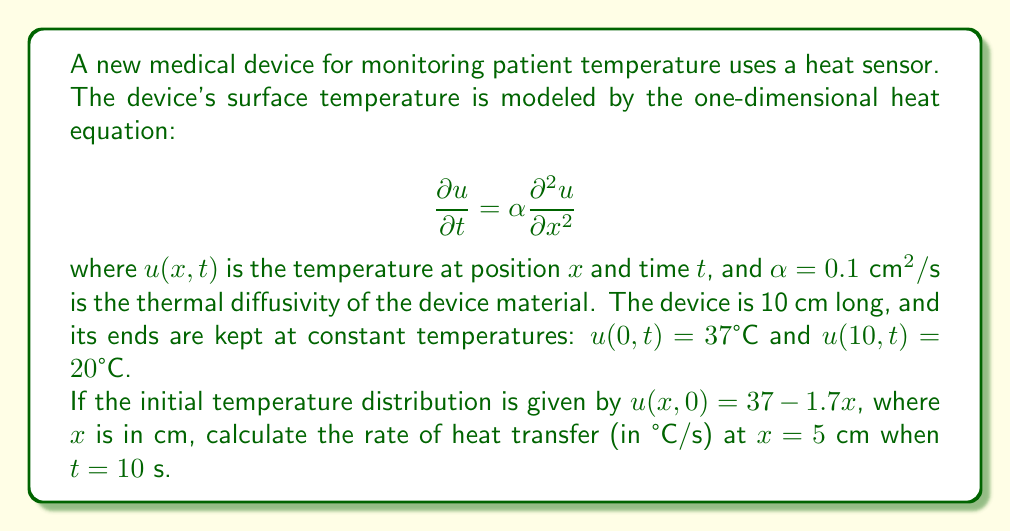Teach me how to tackle this problem. To solve this problem, we need to follow these steps:

1) The general solution to the given heat equation with the specified boundary conditions is:

   $$u(x,t) = 37 - 1.7x + \sum_{n=1}^{\infty} B_n \sin(\frac{n\pi x}{10}) e^{-\alpha(\frac{n\pi}{10})^2 t}$$

   where $B_n$ are constants determined by the initial condition.

2) The rate of heat transfer is given by $-\alpha \frac{\partial^2 u}{\partial x^2}$. We need to calculate this at $x = 5$ cm and $t = 10$ s.

3) Taking the second derivative of $u$ with respect to $x$:

   $$\frac{\partial^2 u}{\partial x^2} = \sum_{n=1}^{\infty} -B_n (\frac{n\pi}{10})^2 \sin(\frac{n\pi x}{10}) e^{-\alpha(\frac{n\pi}{10})^2 t}$$

4) To find $B_n$, we use the initial condition:

   $$37 - 1.7x = 37 - 1.7x + \sum_{n=1}^{\infty} B_n \sin(\frac{n\pi x}{10})$$

   This implies:

   $$B_n = \frac{2}{10} \int_0^{10} (37 - 1.7x) \sin(\frac{n\pi x}{10}) dx = \frac{34}{n\pi} (1 - (-1)^n)$$

5) Now, we can calculate the rate of heat transfer:

   $$\text{Rate} = -\alpha \sum_{n=1}^{\infty} B_n (\frac{n\pi}{10})^2 \sin(\frac{n\pi x}{2}) e^{-\alpha(\frac{n\pi}{10})^2 t}$$

6) Substituting the values $\alpha = 0.1$, $x = 5$, and $t = 10$:

   $$\text{Rate} = -0.1 \sum_{n=1}^{\infty} \frac{34}{n\pi} (1 - (-1)^n) (\frac{n\pi}{10})^2 \sin(\frac{n\pi}{2}) e^{-0.1(\frac{n\pi}{10})^2 10}$$

7) This series converges rapidly. Calculating the first few terms (odd n only, as even n terms are zero):

   For $n = 1$: $-0.0214$ °C/s
   For $n = 3$: $-0.0006$ °C/s
   For $n = 5$: $-0.00002$ °C/s

8) Summing these terms:

   $$\text{Rate} \approx -0.022 \text{ °C/s}$$
Answer: $-0.022 \text{ °C/s}$ 